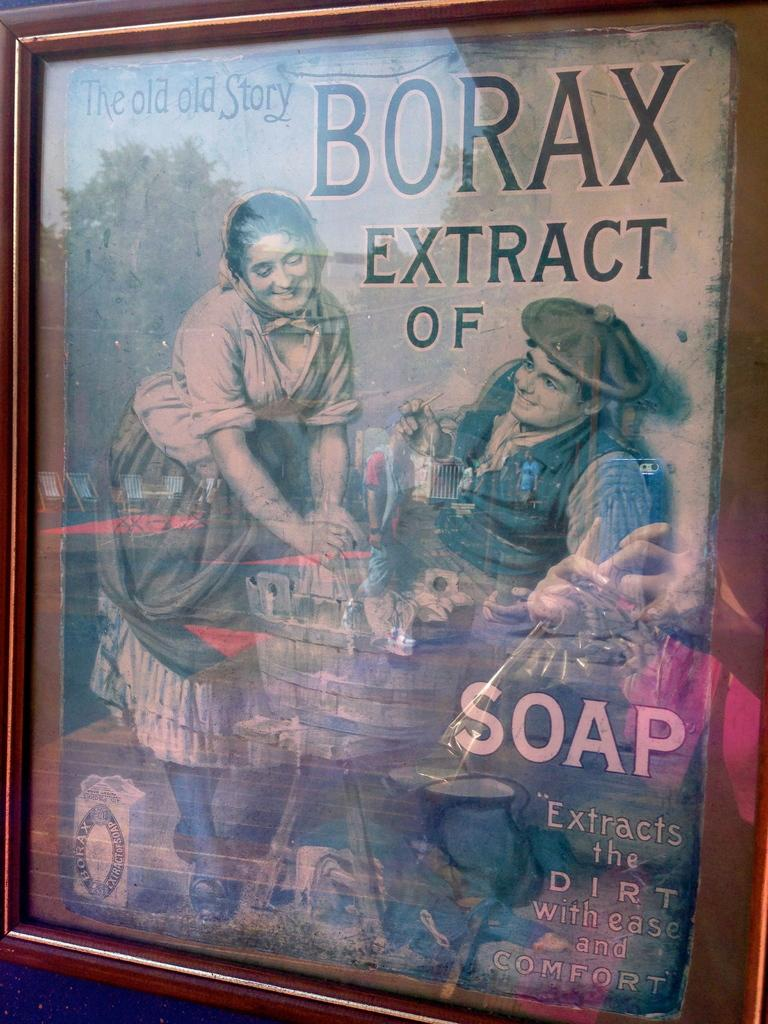<image>
Relay a brief, clear account of the picture shown. An image of an old ad for Borax extract of soap. 